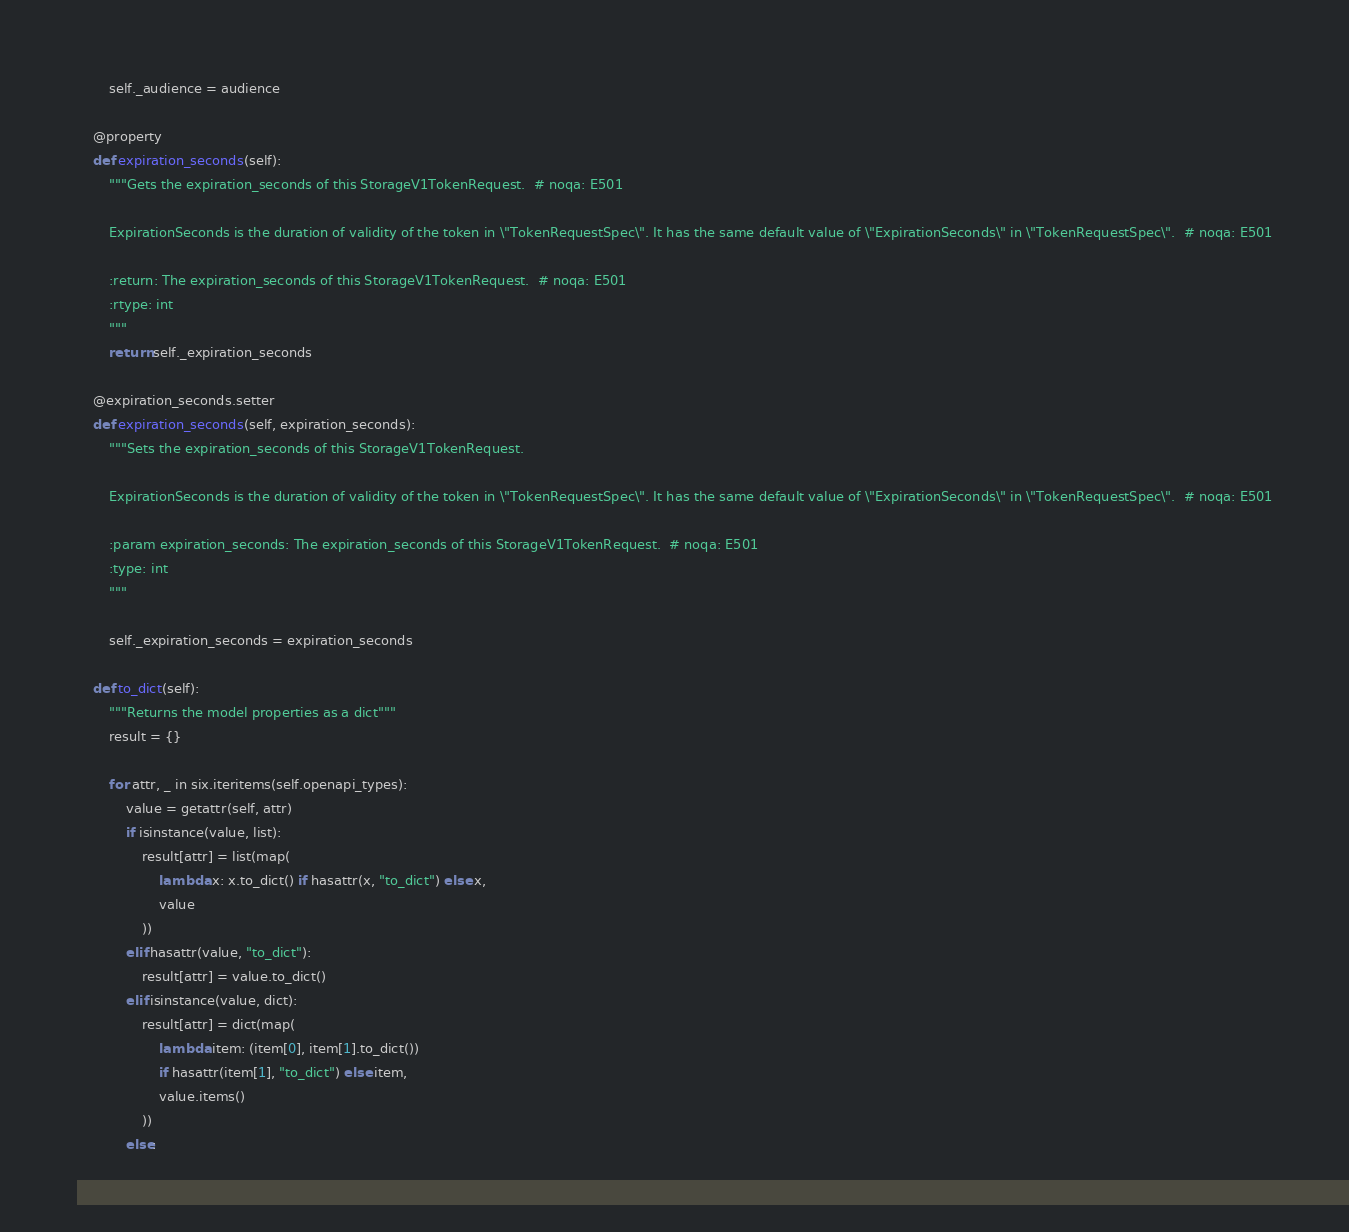Convert code to text. <code><loc_0><loc_0><loc_500><loc_500><_Python_>        self._audience = audience

    @property
    def expiration_seconds(self):
        """Gets the expiration_seconds of this StorageV1TokenRequest.  # noqa: E501

        ExpirationSeconds is the duration of validity of the token in \"TokenRequestSpec\". It has the same default value of \"ExpirationSeconds\" in \"TokenRequestSpec\".  # noqa: E501

        :return: The expiration_seconds of this StorageV1TokenRequest.  # noqa: E501
        :rtype: int
        """
        return self._expiration_seconds

    @expiration_seconds.setter
    def expiration_seconds(self, expiration_seconds):
        """Sets the expiration_seconds of this StorageV1TokenRequest.

        ExpirationSeconds is the duration of validity of the token in \"TokenRequestSpec\". It has the same default value of \"ExpirationSeconds\" in \"TokenRequestSpec\".  # noqa: E501

        :param expiration_seconds: The expiration_seconds of this StorageV1TokenRequest.  # noqa: E501
        :type: int
        """

        self._expiration_seconds = expiration_seconds

    def to_dict(self):
        """Returns the model properties as a dict"""
        result = {}

        for attr, _ in six.iteritems(self.openapi_types):
            value = getattr(self, attr)
            if isinstance(value, list):
                result[attr] = list(map(
                    lambda x: x.to_dict() if hasattr(x, "to_dict") else x,
                    value
                ))
            elif hasattr(value, "to_dict"):
                result[attr] = value.to_dict()
            elif isinstance(value, dict):
                result[attr] = dict(map(
                    lambda item: (item[0], item[1].to_dict())
                    if hasattr(item[1], "to_dict") else item,
                    value.items()
                ))
            else:</code> 